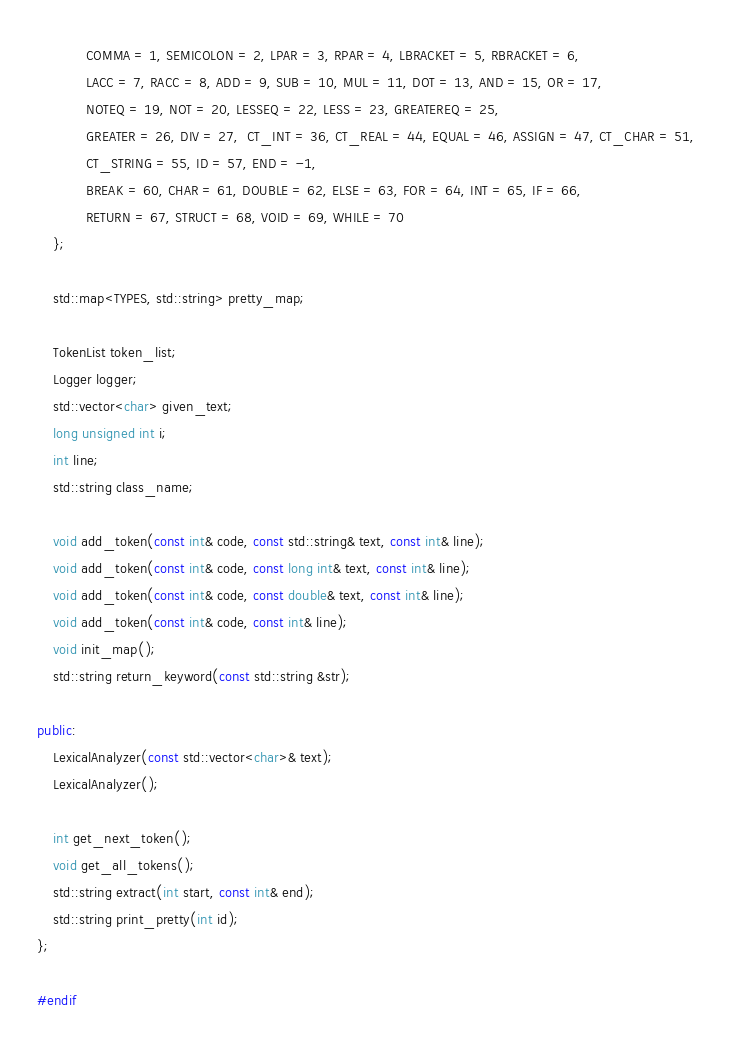Convert code to text. <code><loc_0><loc_0><loc_500><loc_500><_C++_>        	COMMA = 1, SEMICOLON = 2, LPAR = 3, RPAR = 4, LBRACKET = 5, RBRACKET = 6,
            LACC = 7, RACC = 8, ADD = 9, SUB = 10, MUL = 11, DOT = 13, AND = 15, OR = 17,
            NOTEQ = 19, NOT = 20, LESSEQ = 22, LESS = 23, GREATEREQ = 25,
            GREATER = 26, DIV = 27,  CT_INT = 36, CT_REAL = 44, EQUAL = 46, ASSIGN = 47, CT_CHAR = 51,
            CT_STRING = 55, ID = 57, END = -1,
            BREAK = 60, CHAR = 61, DOUBLE = 62, ELSE = 63, FOR = 64, INT = 65, IF = 66,
            RETURN = 67, STRUCT = 68, VOID = 69, WHILE = 70
    };

    std::map<TYPES, std::string> pretty_map;

    TokenList token_list;
    Logger logger;
    std::vector<char> given_text;
    long unsigned int i;
    int line;
    std::string class_name;

    void add_token(const int& code, const std::string& text, const int& line);
    void add_token(const int& code, const long int& text, const int& line);
    void add_token(const int& code, const double& text, const int& line);
    void add_token(const int& code, const int& line);
    void init_map();
    std::string return_keyword(const std::string &str);
    
public:
    LexicalAnalyzer(const std::vector<char>& text);
    LexicalAnalyzer();

    int get_next_token();
    void get_all_tokens();
    std::string extract(int start, const int& end);
    std::string print_pretty(int id);
};

#endif</code> 